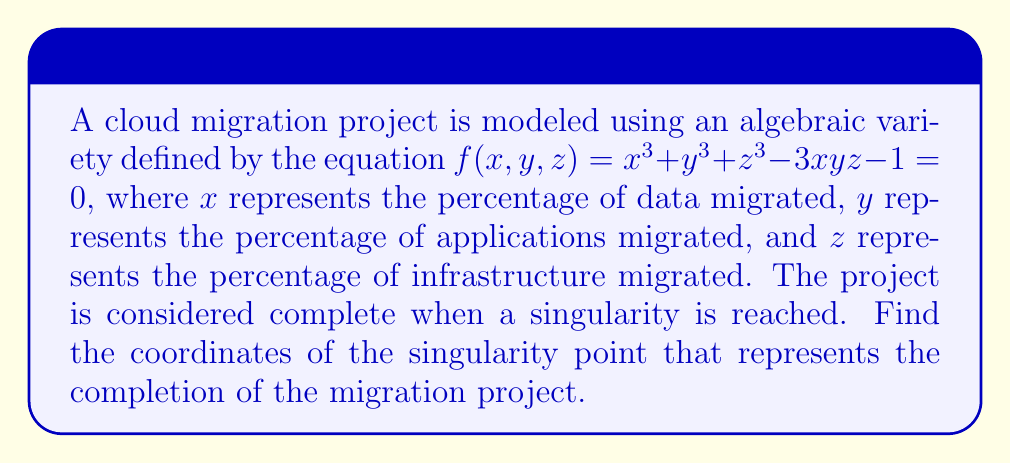What is the answer to this math problem? To find the singularity point, we need to follow these steps:

1. Calculate the partial derivatives of $f(x, y, z)$ with respect to $x$, $y$, and $z$:

   $$\frac{\partial f}{\partial x} = 3x^2 - 3yz$$
   $$\frac{\partial f}{\partial y} = 3y^2 - 3xz$$
   $$\frac{\partial f}{\partial z} = 3z^2 - 3xy$$

2. Set each partial derivative equal to zero:

   $$3x^2 - 3yz = 0$$
   $$3y^2 - 3xz = 0$$
   $$3z^2 - 3xy = 0$$

3. Simplify the equations:

   $$x^2 = yz$$
   $$y^2 = xz$$
   $$z^2 = xy$$

4. From these equations, we can deduce that $x = y = z$. Let's substitute this into one of the equations:

   $$x^2 = x^2$$

5. This is true for any value of $x$. To find the specific value, we need to use the original equation:

   $$x^3 + x^3 + x^3 - 3x^3 - 1 = 0$$
   $$3x^3 - 3x^3 - 1 = 0$$
   $$-1 = 0$$

6. This equation is satisfied when $x = 1$, $y = 1$, and $z = 1$.

7. Verify that this point satisfies the original equation:

   $$f(1, 1, 1) = 1^3 + 1^3 + 1^3 - 3(1)(1)(1) - 1 = 3 - 3 - 1 = -1 = 0$$

Therefore, the singularity point is at (1, 1, 1), representing 100% completion of data, application, and infrastructure migration.
Answer: (1, 1, 1) 